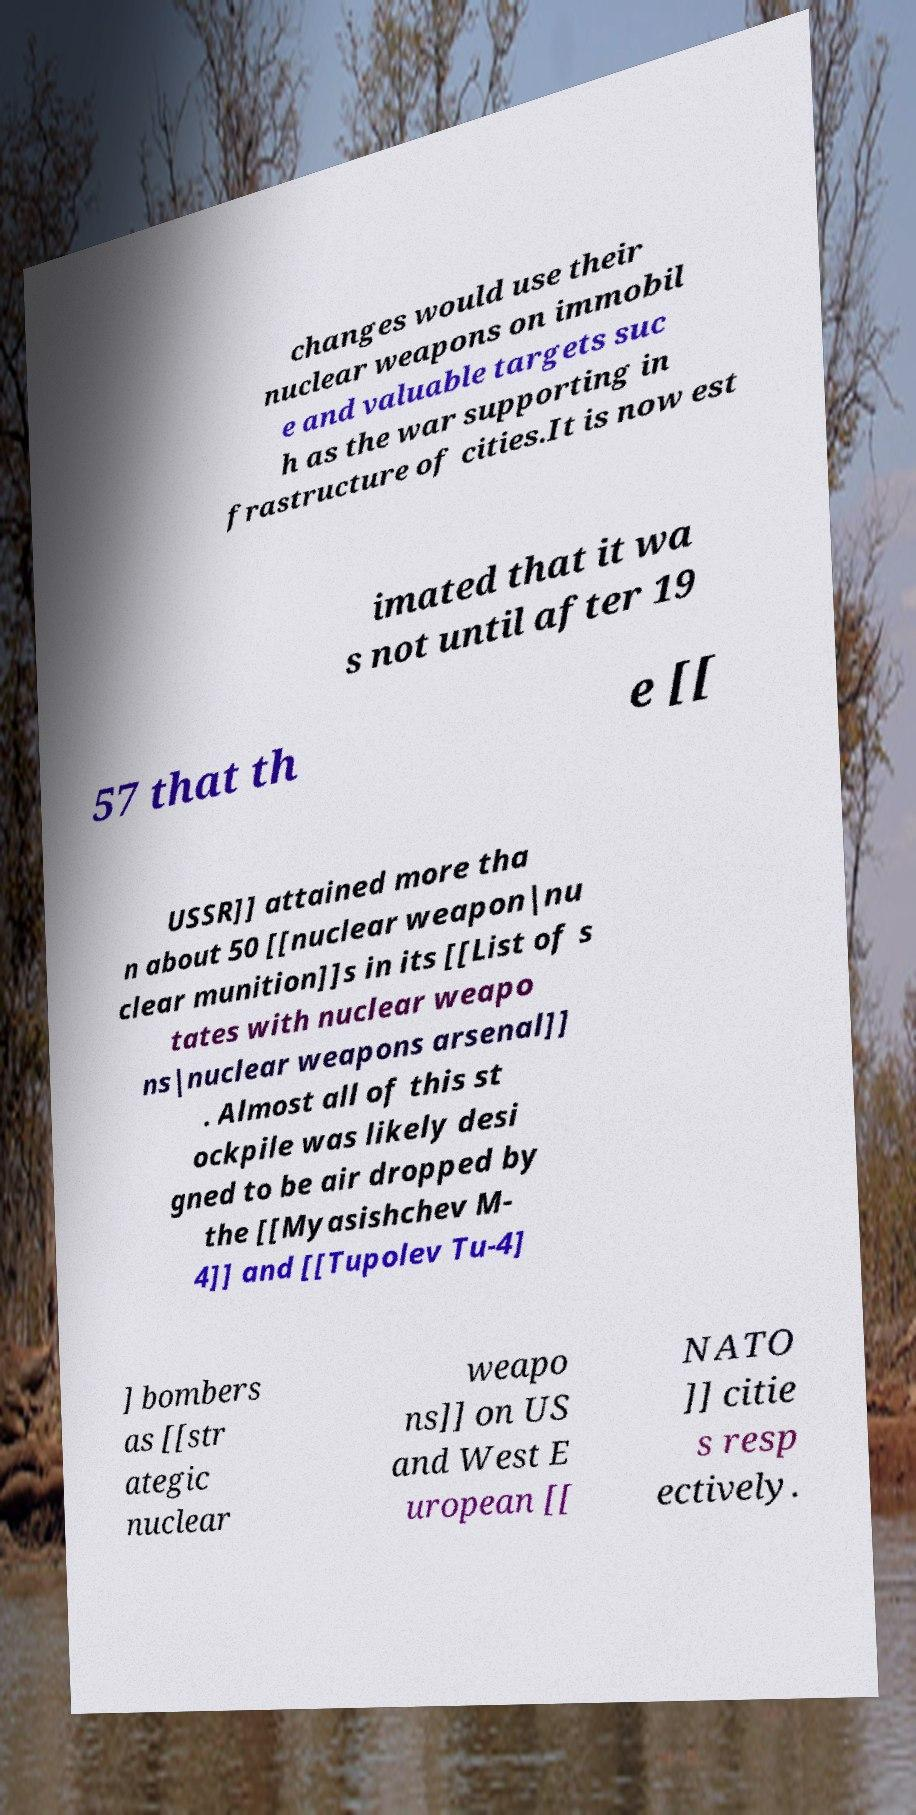Could you assist in decoding the text presented in this image and type it out clearly? changes would use their nuclear weapons on immobil e and valuable targets suc h as the war supporting in frastructure of cities.It is now est imated that it wa s not until after 19 57 that th e [[ USSR]] attained more tha n about 50 [[nuclear weapon|nu clear munition]]s in its [[List of s tates with nuclear weapo ns|nuclear weapons arsenal]] . Almost all of this st ockpile was likely desi gned to be air dropped by the [[Myasishchev M- 4]] and [[Tupolev Tu-4] ] bombers as [[str ategic nuclear weapo ns]] on US and West E uropean [[ NATO ]] citie s resp ectively. 